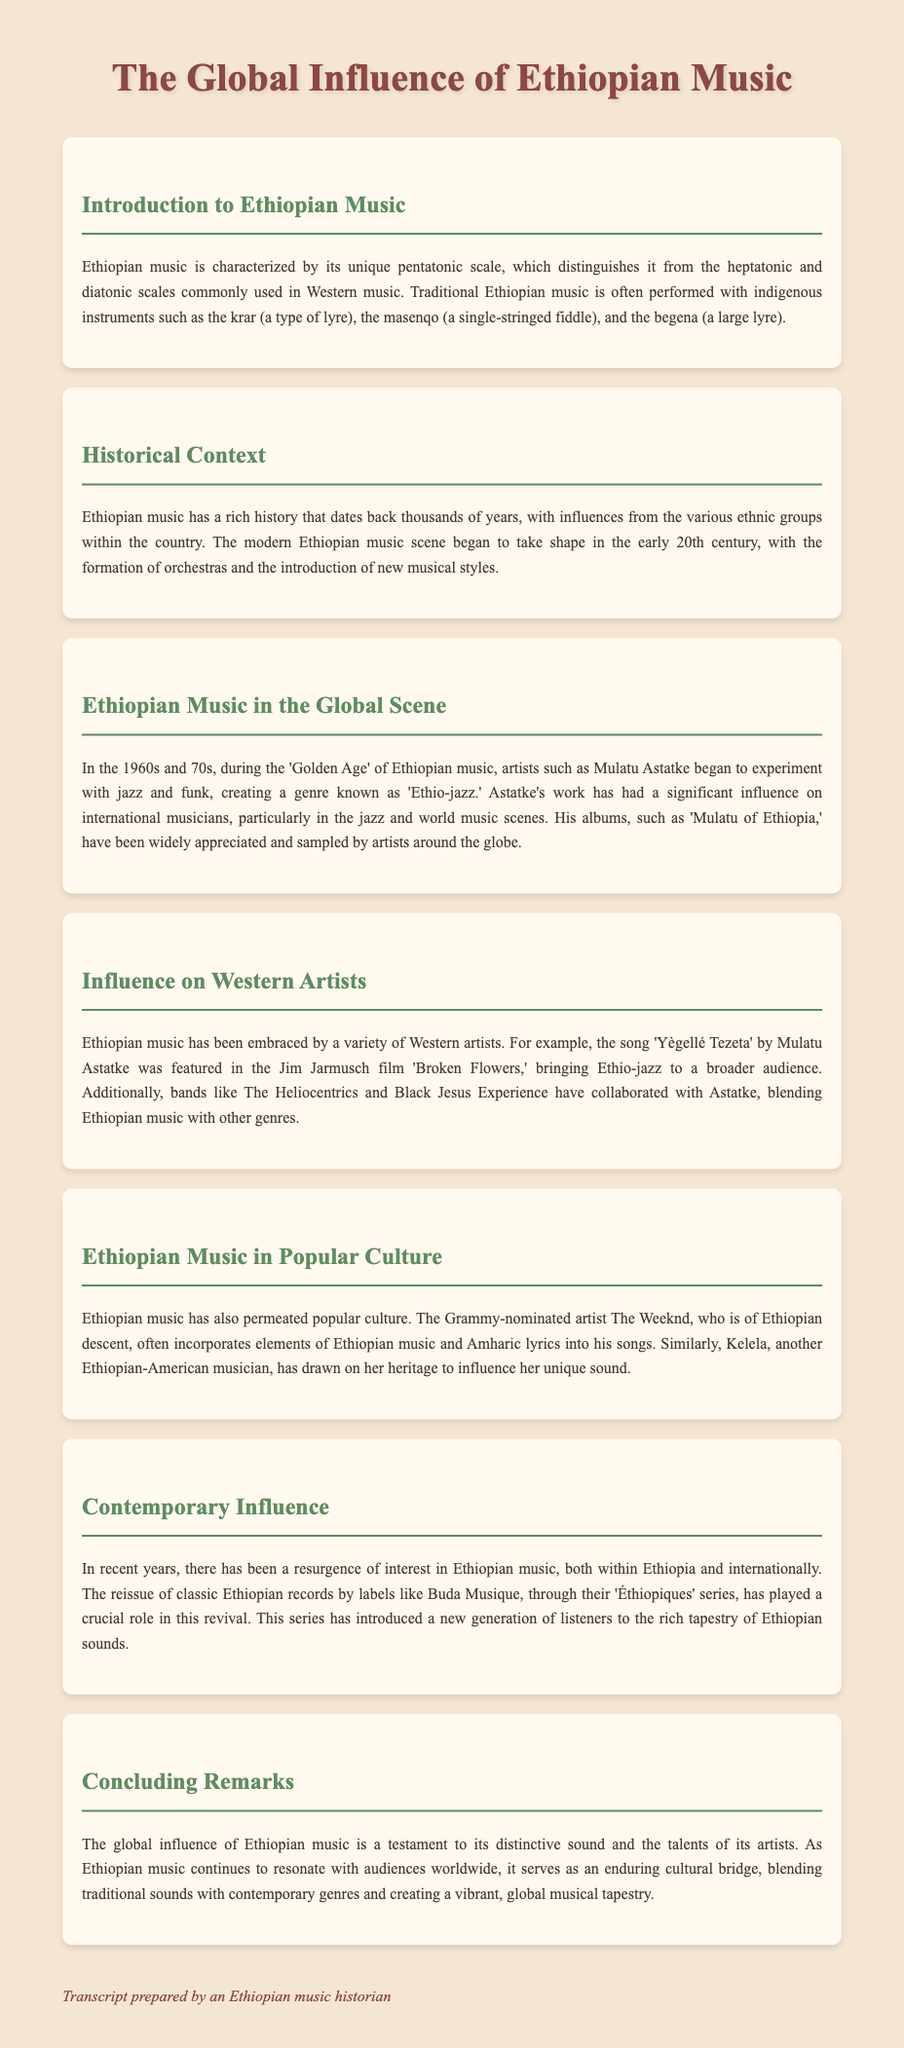What is the unique scale characteristic of Ethiopian music? The document mentions that Ethiopian music is characterized by its unique pentatonic scale.
Answer: pentatonic scale Who is a prominent artist associated with Ethio-jazz? The section on Ethiopian music in the global scene identifies Mulatu Astatke as a key figure in Ethio-jazz.
Answer: Mulatu Astatke In what decades did the 'Golden Age' of Ethiopian music occur? The document states that the 'Golden Age' of Ethiopian music took place during the 1960s and 70s.
Answer: 1960s and 70s What film featured the song 'Yègellé Tezeta'? The document states that 'Yègellé Tezeta' by Mulatu Astatke was featured in the Jim Jarmusch film 'Broken Flowers.'
Answer: Broken Flowers Which Grammy-nominated artist incorporates Ethiopian music elements? The document mentions The Weeknd as a Grammy-nominated artist of Ethiopian descent who incorporates elements of Ethiopian music.
Answer: The Weeknd What is the purpose of the 'Éthiopiques' series? The document explains that the 'Éthiopiques' series aims to introduce a new generation of listeners to Ethiopian sounds.
Answer: Introduce sounds to new listeners What genre did Mulatu Astatke fuse Ethiopian music with? According to the document, Mulatu Astatke experimented with jazz and funk, creating a genre known as 'Ethio-jazz.'
Answer: Ethio-jazz What type of instruments are common in traditional Ethiopian music? The document lists indigenous instruments such as the krar, masenqo, and begena as common in Ethiopian music.
Answer: krar, masenqo, begena What does the document refer to Ethiopian music as a cultural bridge? The concluding remarks highlight that Ethiopian music serves as an enduring cultural bridge by blending traditional sounds with contemporary genres.
Answer: cultural bridge 